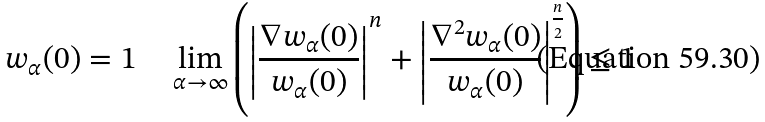<formula> <loc_0><loc_0><loc_500><loc_500>w _ { \alpha } ( 0 ) = 1 \quad \lim _ { \alpha \to \infty } \left ( \left | \frac { \nabla w _ { \alpha } ( 0 ) } { w _ { \alpha } ( 0 ) } \right | ^ { n } + \left | \frac { \nabla ^ { 2 } w _ { \alpha } ( 0 ) } { w _ { \alpha } ( 0 ) } \right | ^ { \frac { n } { 2 } } \right ) \leq 1</formula> 